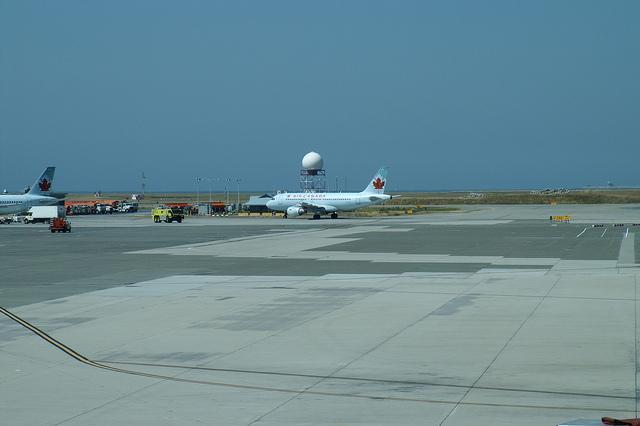How many planes?
Give a very brief answer. 2. How many planes are in the picture?
Give a very brief answer. 2. How many engines on the plane?
Give a very brief answer. 2. How many airplanes are there?
Give a very brief answer. 2. How many airplanes can you see?
Give a very brief answer. 2. 